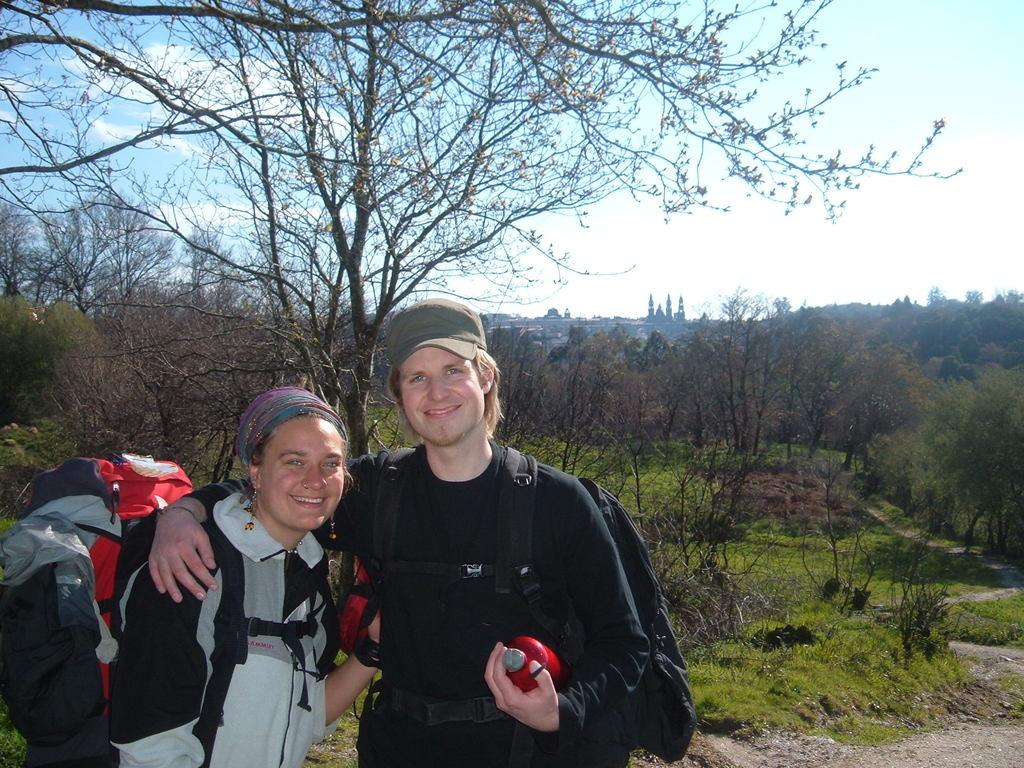Who is present in the image? There is a couple in the image. What are the couple doing in the image? Both individuals in the couple are smiling. What are they carrying on their shoulders? They are wearing bags on their shoulders. What can be seen in the background of the image? There are trees and the sky visible in the background of the image. What type of iron can be seen in the couple's hands in the image? There is no iron present in the image; the couple is wearing bags on their shoulders. Is there a fight happening between the couple in the image? No, the couple is smiling in the image, which suggests they are not engaged in a fight. 